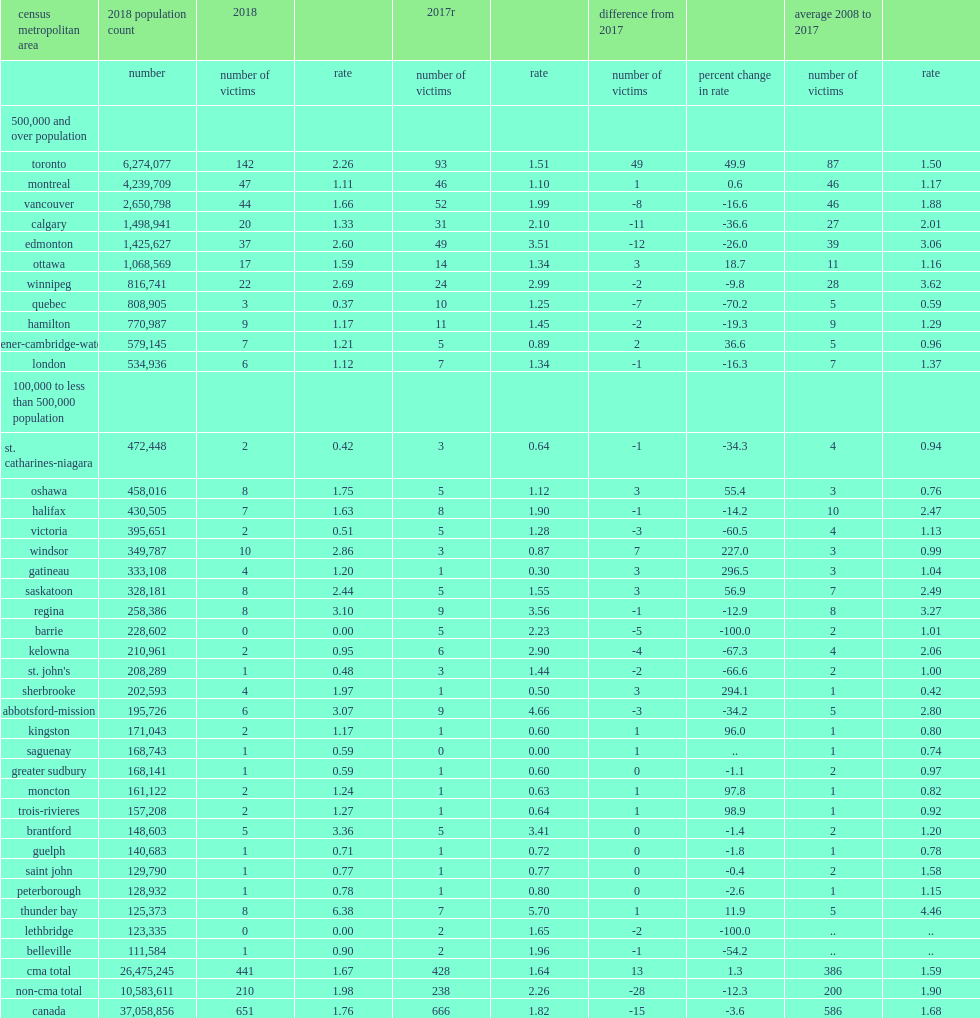List the cmas where reported the largest declines and the greatest increases. Edmonton calgary vancouver toronto windsor. In windsor,what was the number of victims in 2018 and difference from 2017 respectively? 10.0 7.0. 